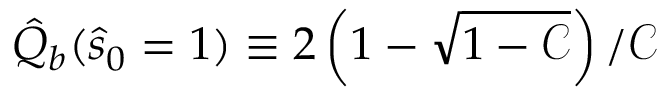Convert formula to latex. <formula><loc_0><loc_0><loc_500><loc_500>\hat { Q } _ { b } ( \hat { s } _ { 0 } = 1 ) \equiv 2 \left ( 1 - \sqrt { 1 - \mathcal { C } } \right ) / \mathcal { C }</formula> 